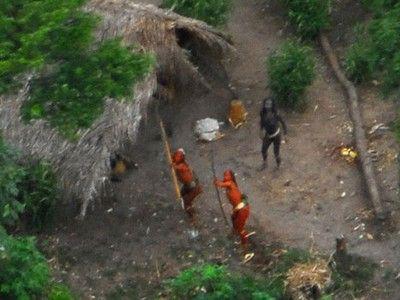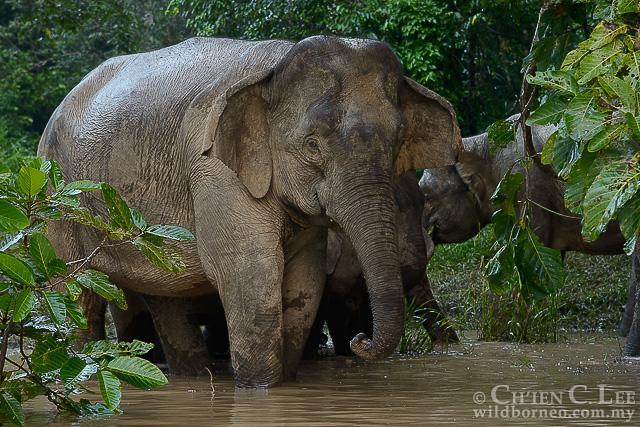The first image is the image on the left, the second image is the image on the right. For the images shown, is this caption "There are elephants near a body of water." true? Answer yes or no. Yes. The first image is the image on the left, the second image is the image on the right. Assess this claim about the two images: "The elephant in the image on the left are standing in a grassy wooded area.". Correct or not? Answer yes or no. No. 